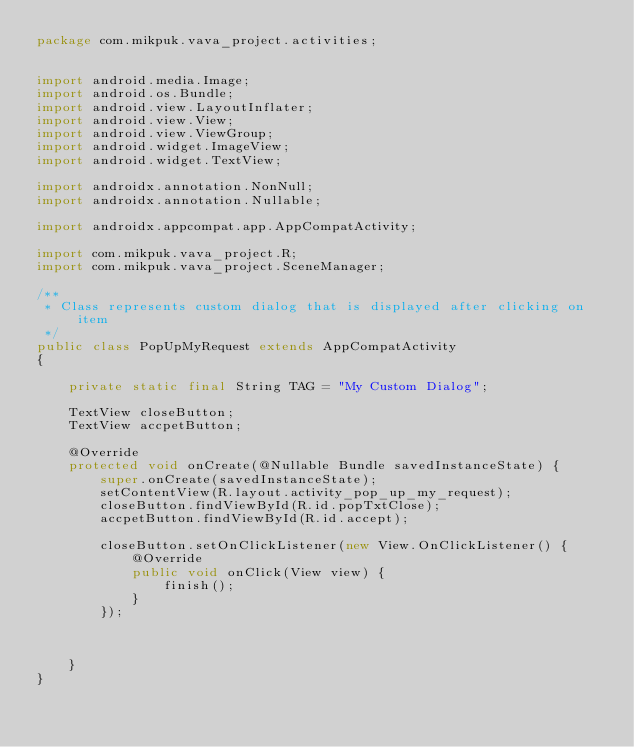Convert code to text. <code><loc_0><loc_0><loc_500><loc_500><_Java_>package com.mikpuk.vava_project.activities;


import android.media.Image;
import android.os.Bundle;
import android.view.LayoutInflater;
import android.view.View;
import android.view.ViewGroup;
import android.widget.ImageView;
import android.widget.TextView;

import androidx.annotation.NonNull;
import androidx.annotation.Nullable;

import androidx.appcompat.app.AppCompatActivity;

import com.mikpuk.vava_project.R;
import com.mikpuk.vava_project.SceneManager;

/**
 * Class represents custom dialog that is displayed after clicking on item
 */
public class PopUpMyRequest extends AppCompatActivity
{

    private static final String TAG = "My Custom Dialog";

    TextView closeButton;
    TextView accpetButton;

    @Override
    protected void onCreate(@Nullable Bundle savedInstanceState) {
        super.onCreate(savedInstanceState);
        setContentView(R.layout.activity_pop_up_my_request);
        closeButton.findViewById(R.id.popTxtClose);
        accpetButton.findViewById(R.id.accept);

        closeButton.setOnClickListener(new View.OnClickListener() {
            @Override
            public void onClick(View view) {
                finish();
            }
        });



    }
}
</code> 